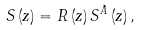<formula> <loc_0><loc_0><loc_500><loc_500>S \left ( z \right ) = R \left ( z \right ) S ^ { A } \left ( z \right ) ,</formula> 